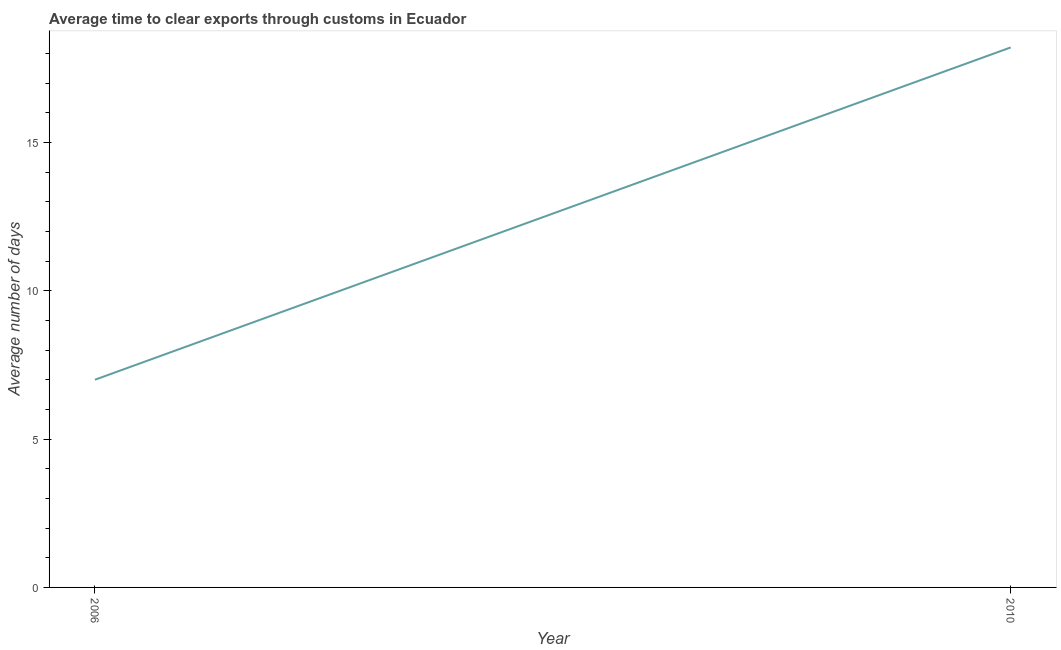Across all years, what is the minimum time to clear exports through customs?
Keep it short and to the point. 7. What is the sum of the time to clear exports through customs?
Give a very brief answer. 25.2. What is the difference between the time to clear exports through customs in 2006 and 2010?
Offer a very short reply. -11.2. What is the median time to clear exports through customs?
Give a very brief answer. 12.6. In how many years, is the time to clear exports through customs greater than 8 days?
Provide a short and direct response. 1. Do a majority of the years between 2010 and 2006 (inclusive) have time to clear exports through customs greater than 12 days?
Provide a succinct answer. No. What is the ratio of the time to clear exports through customs in 2006 to that in 2010?
Provide a short and direct response. 0.38. Is the time to clear exports through customs in 2006 less than that in 2010?
Give a very brief answer. Yes. How many years are there in the graph?
Offer a terse response. 2. What is the difference between two consecutive major ticks on the Y-axis?
Ensure brevity in your answer.  5. Are the values on the major ticks of Y-axis written in scientific E-notation?
Give a very brief answer. No. Does the graph contain grids?
Offer a terse response. No. What is the title of the graph?
Your answer should be very brief. Average time to clear exports through customs in Ecuador. What is the label or title of the Y-axis?
Give a very brief answer. Average number of days. What is the Average number of days of 2006?
Offer a terse response. 7. What is the Average number of days in 2010?
Your answer should be very brief. 18.2. What is the ratio of the Average number of days in 2006 to that in 2010?
Provide a succinct answer. 0.39. 